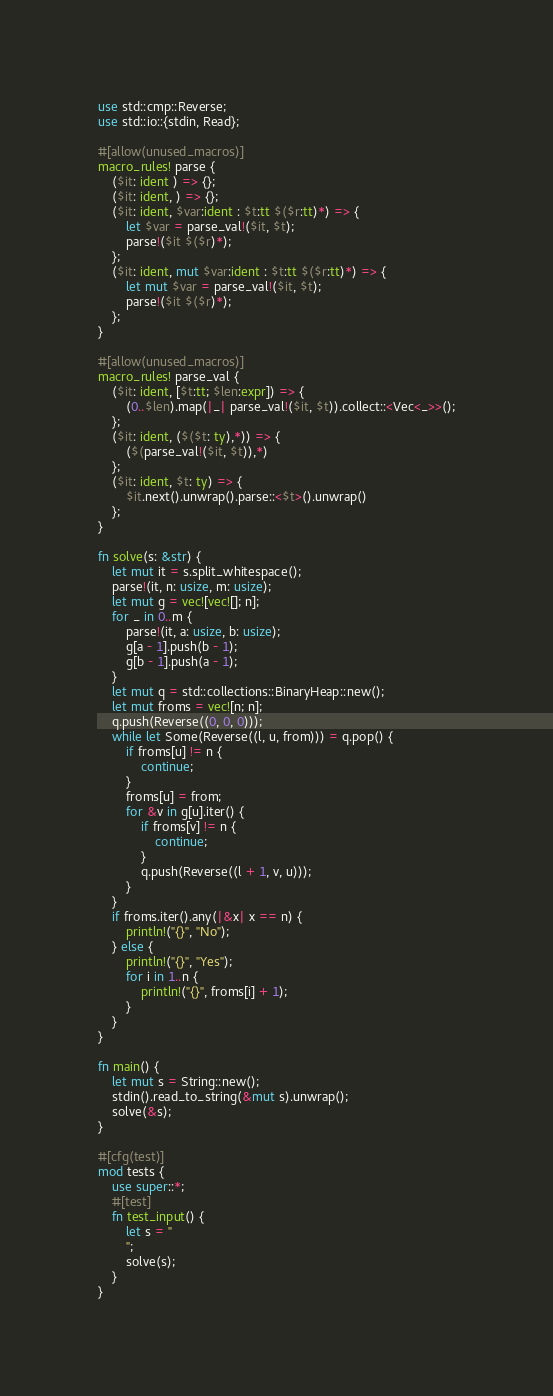Convert code to text. <code><loc_0><loc_0><loc_500><loc_500><_Rust_>use std::cmp::Reverse;
use std::io::{stdin, Read};

#[allow(unused_macros)]
macro_rules! parse {
    ($it: ident ) => {};
    ($it: ident, ) => {};
    ($it: ident, $var:ident : $t:tt $($r:tt)*) => {
        let $var = parse_val!($it, $t);
        parse!($it $($r)*);
    };
    ($it: ident, mut $var:ident : $t:tt $($r:tt)*) => {
        let mut $var = parse_val!($it, $t);
        parse!($it $($r)*);
    };
}

#[allow(unused_macros)]
macro_rules! parse_val {
    ($it: ident, [$t:tt; $len:expr]) => {
        (0..$len).map(|_| parse_val!($it, $t)).collect::<Vec<_>>();
    };
    ($it: ident, ($($t: ty),*)) => {
        ($(parse_val!($it, $t)),*)
    };
    ($it: ident, $t: ty) => {
        $it.next().unwrap().parse::<$t>().unwrap()
    };
}

fn solve(s: &str) {
    let mut it = s.split_whitespace();
    parse!(it, n: usize, m: usize);
    let mut g = vec![vec![]; n];
    for _ in 0..m {
        parse!(it, a: usize, b: usize);
        g[a - 1].push(b - 1);
        g[b - 1].push(a - 1);
    }
    let mut q = std::collections::BinaryHeap::new();
    let mut froms = vec![n; n];
    q.push(Reverse((0, 0, 0)));
    while let Some(Reverse((l, u, from))) = q.pop() {
        if froms[u] != n {
            continue;
        }
        froms[u] = from;
        for &v in g[u].iter() {
            if froms[v] != n {
                continue;
            }
            q.push(Reverse((l + 1, v, u)));
        }
    }
    if froms.iter().any(|&x| x == n) {
        println!("{}", "No");
    } else {
        println!("{}", "Yes");
        for i in 1..n {
            println!("{}", froms[i] + 1);
        }
    }
}

fn main() {
    let mut s = String::new();
    stdin().read_to_string(&mut s).unwrap();
    solve(&s);
}

#[cfg(test)]
mod tests {
    use super::*;
    #[test]
    fn test_input() {
        let s = "
        ";
        solve(s);
    }
}
</code> 